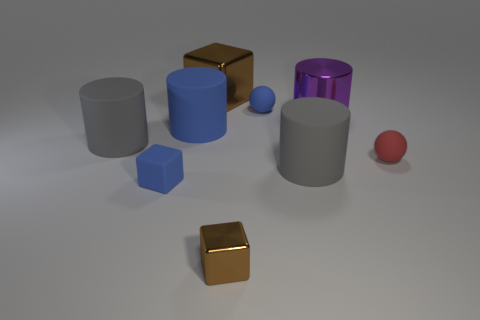Can you describe the difference in textures between the objects shown? Certainly. In the image, the objects display a variety of textures. The blue and violet cylinders have a rubber-like texture that appears smooth and matte. The golden cubes, in contrast, showcase a reflective, somewhat glossy surface that simulates metallic properties. The grey cylinders and the blue cube have a dull matte finish, indicative of objects rendered to omit reflection for a more subdued appearance. Lastly, the small red sphere looks velvety, slightly diffusing light rather than reflecting it sharply. 